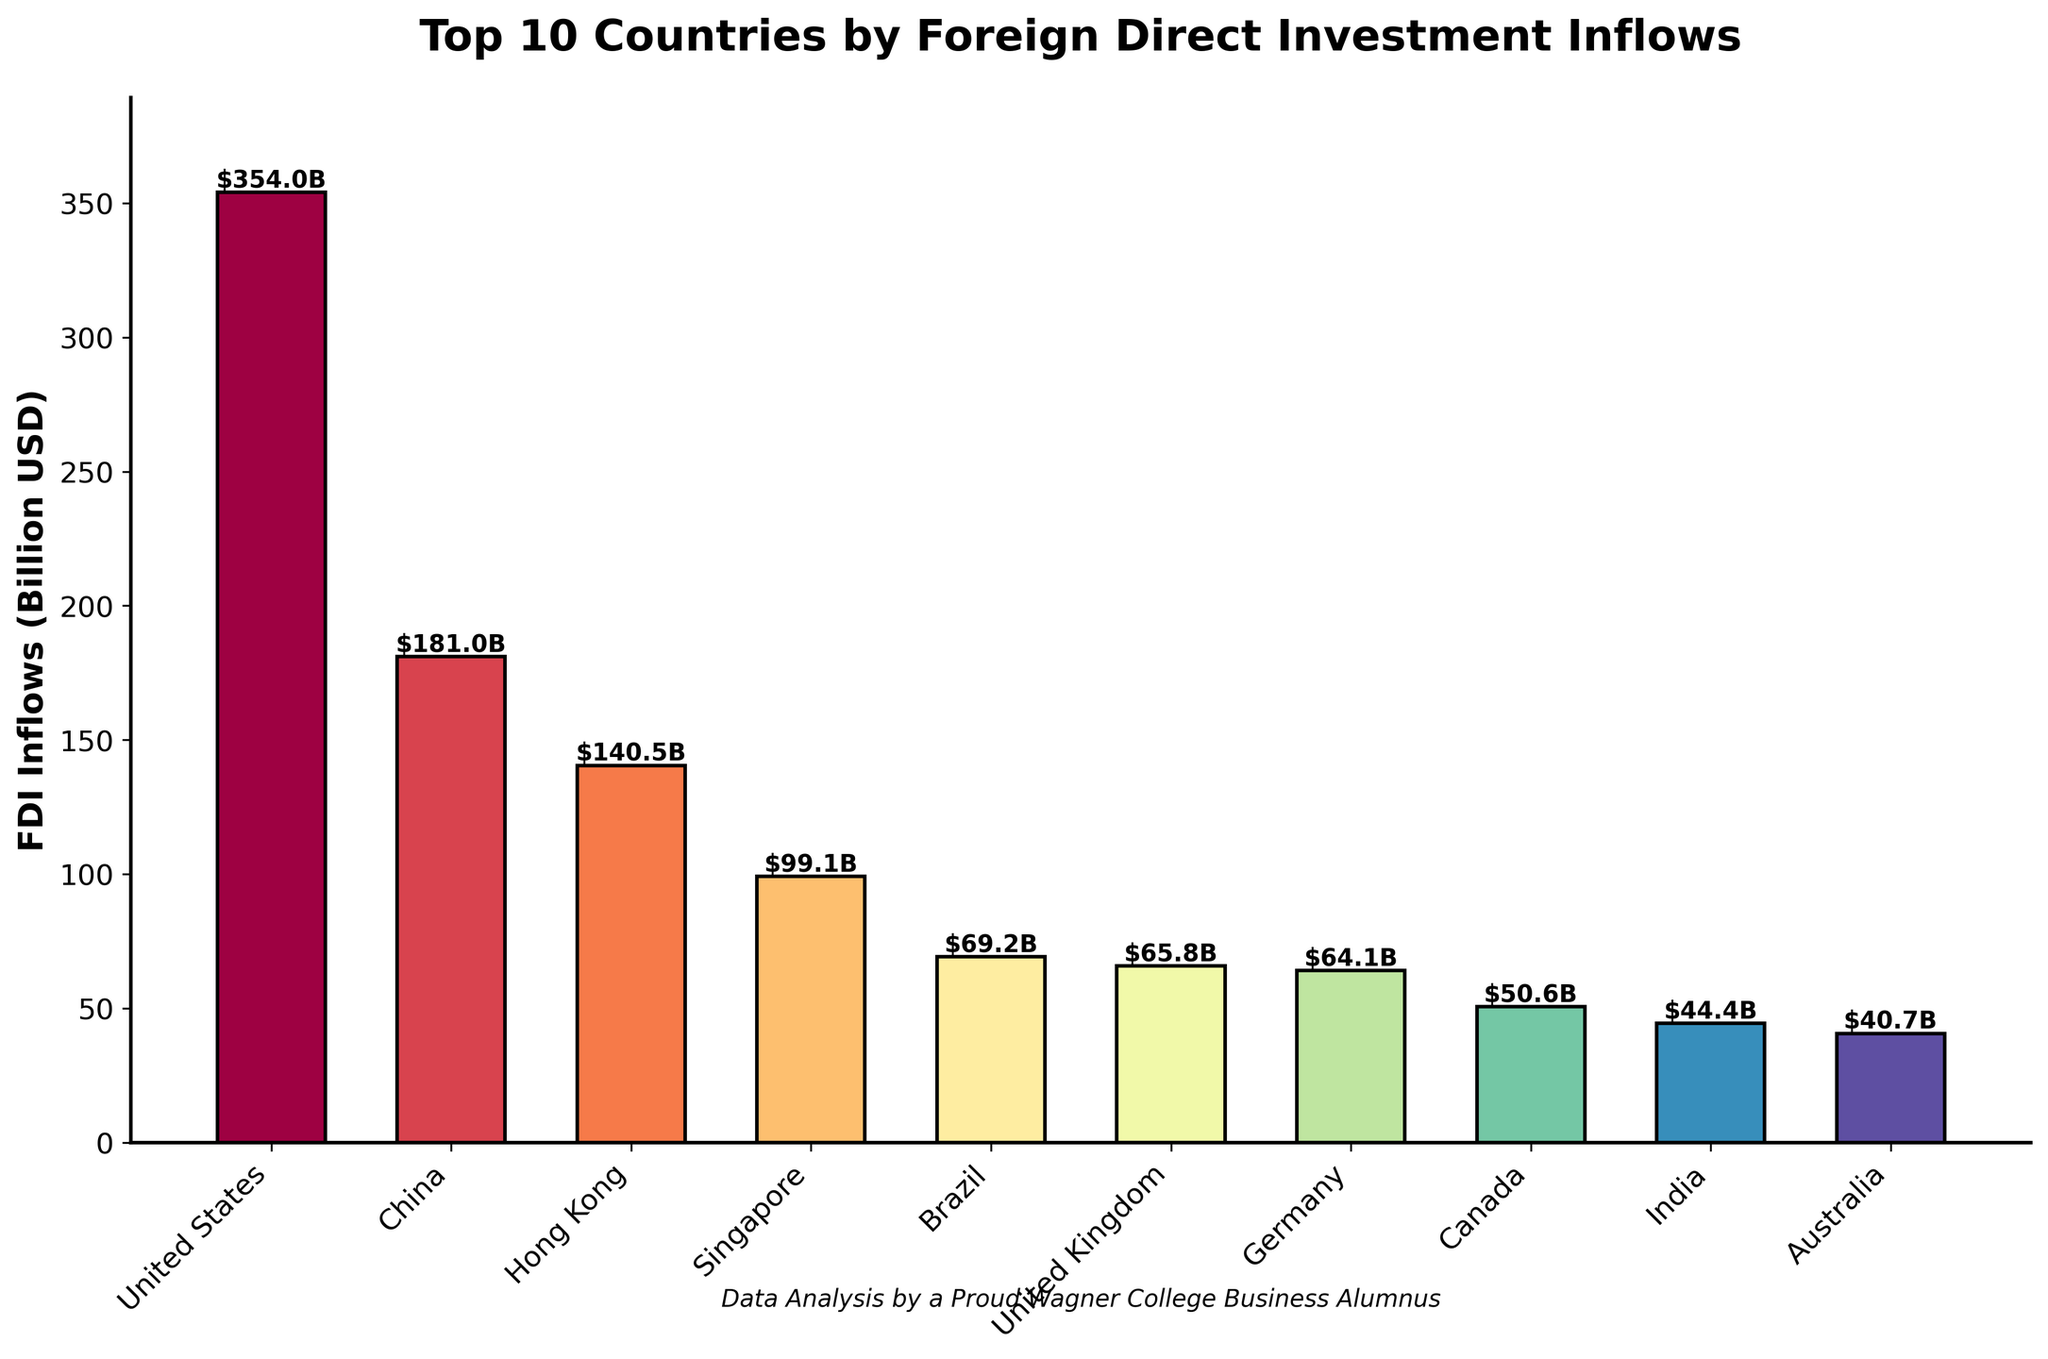What's the country with the highest FDI inflows? The bar chart clearly shows that the United States has the tallest bar with an FDI inflow of $354.0 billion. Therefore, the country with the highest FDI inflows is the United States.
Answer: United States What is the total FDI inflow for the top 3 countries combined? The top 3 countries by FDI inflows are the United States ($354.0 billion), China ($181.0 billion), and Hong Kong ($140.5 billion). Adding them together: $354.0B + $181.0B + $140.5B = $675.5B.
Answer: $675.5 billion How much more FDI does the United States have compared to China? The FDI inflows for the United States is $354.0 billion and for China is $181.0 billion. Subtract China's inflows from the United States' inflows: $354.0B - $181.0B = $173.0B.
Answer: $173.0 billion Which country has the lowest FDI inflows among the top 10? The bar chart shows that Australia has the lowest FDI inflows with a value of $40.7 billion.
Answer: Australia What is the average FDI inflow of the top 10 countries? To find the average FDI inflow, sum up the FDI values of all top 10 countries: $354.0B + $181.0B + $140.5B + $99.1B + $69.2B + $65.8B + $64.1B + $50.6B + $44.4B + $40.7B = $1109.4B. Then divide by the number of countries (10): $1109.4B / 10 = $110.94B.
Answer: $110.94 billion Between the United Kingdom and Germany, which country has higher FDI inflows and by how much? The FDI inflow for the United Kingdom is $65.8 billion, and for Germany, it is $64.1 billion. Subtract Germany's inflow from the United Kingdom's inflow: $65.8B - $64.1B = $1.7B. The United Kingdom has higher FDI inflows by $1.7 billion.
Answer: United Kingdom by $1.7 billion Are there any countries with FDI inflows less than $50 billion? The bar chart shows that India ($44.4 billion) and Australia ($40.7 billion) have FDI inflows less than $50 billion.
Answer: India and Australia 